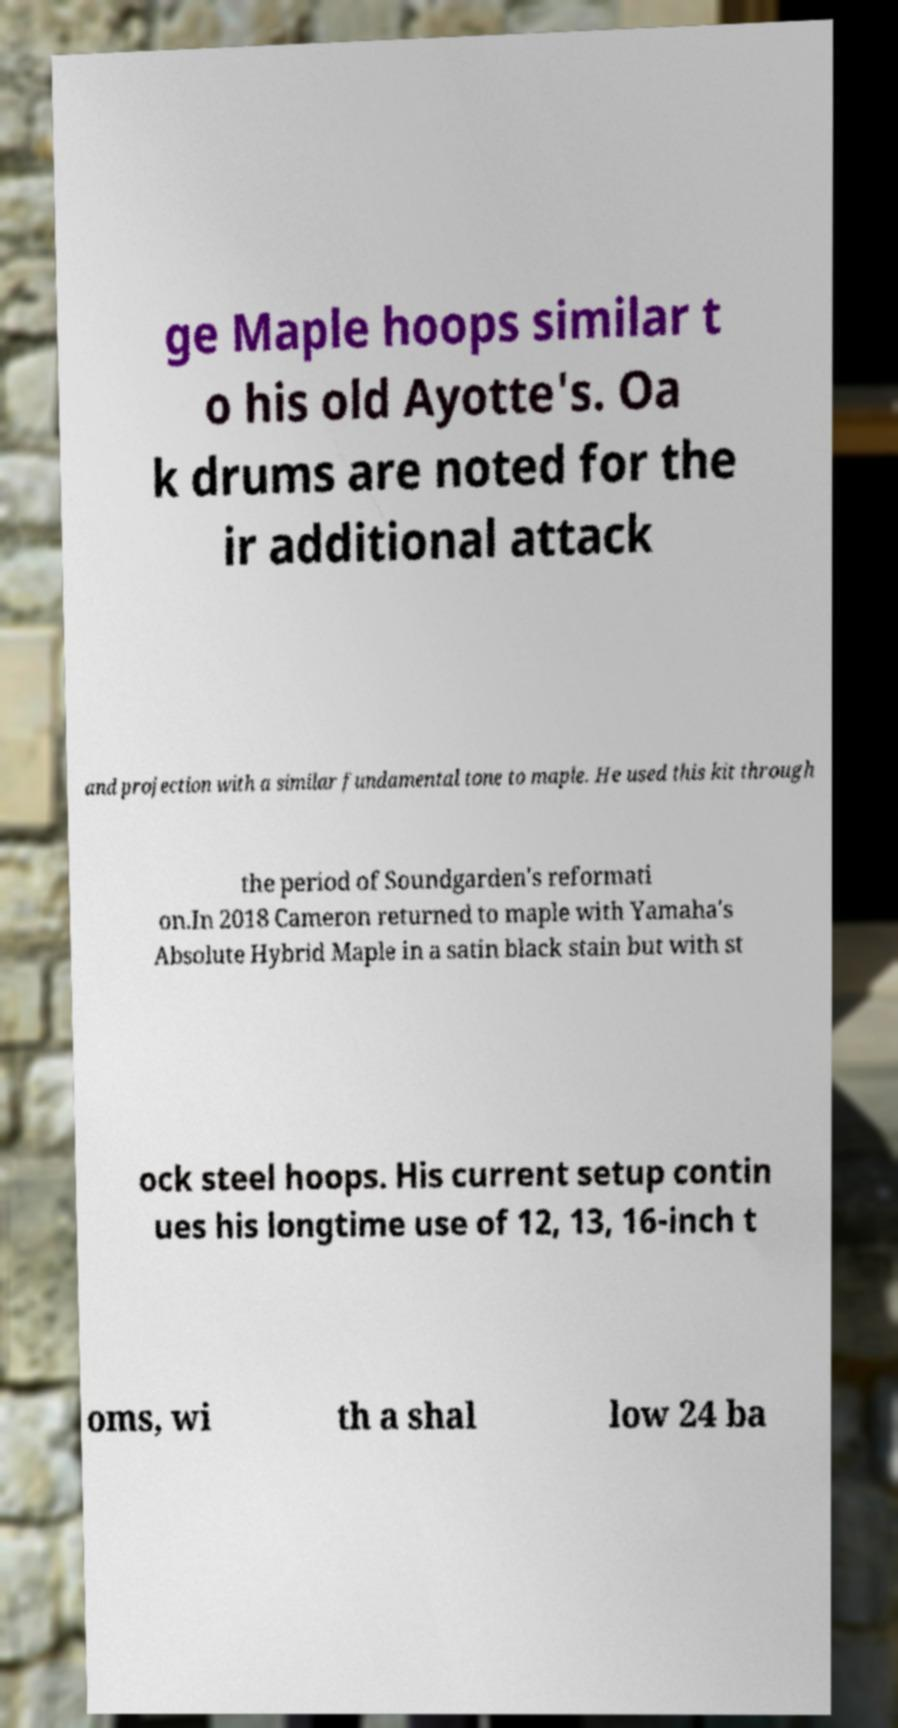There's text embedded in this image that I need extracted. Can you transcribe it verbatim? ge Maple hoops similar t o his old Ayotte's. Oa k drums are noted for the ir additional attack and projection with a similar fundamental tone to maple. He used this kit through the period of Soundgarden's reformati on.In 2018 Cameron returned to maple with Yamaha's Absolute Hybrid Maple in a satin black stain but with st ock steel hoops. His current setup contin ues his longtime use of 12, 13, 16-inch t oms, wi th a shal low 24 ba 